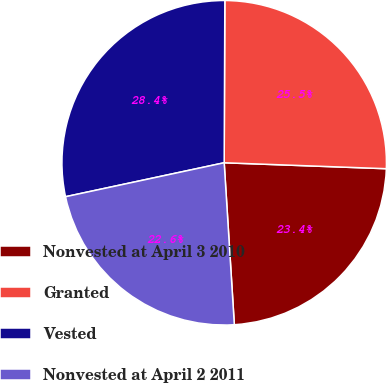Convert chart. <chart><loc_0><loc_0><loc_500><loc_500><pie_chart><fcel>Nonvested at April 3 2010<fcel>Granted<fcel>Vested<fcel>Nonvested at April 2 2011<nl><fcel>23.42%<fcel>25.52%<fcel>28.42%<fcel>22.64%<nl></chart> 